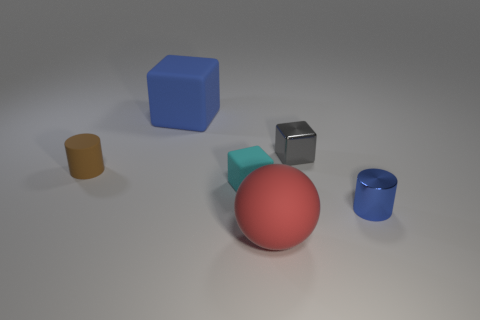Add 4 small brown objects. How many objects exist? 10 Subtract all rubber blocks. How many blocks are left? 1 Subtract all spheres. How many objects are left? 5 Subtract all purple cubes. Subtract all red cylinders. How many cubes are left? 3 Subtract all green rubber objects. Subtract all cylinders. How many objects are left? 4 Add 1 metallic objects. How many metallic objects are left? 3 Add 4 small cyan things. How many small cyan things exist? 5 Subtract 0 blue balls. How many objects are left? 6 